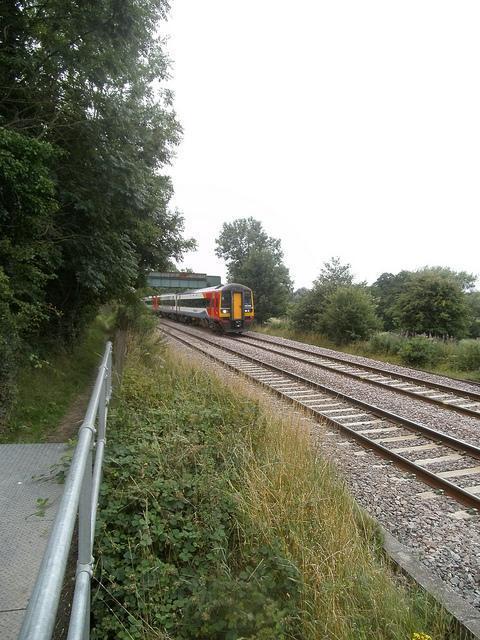How many railroad tracks are there?
Give a very brief answer. 2. 